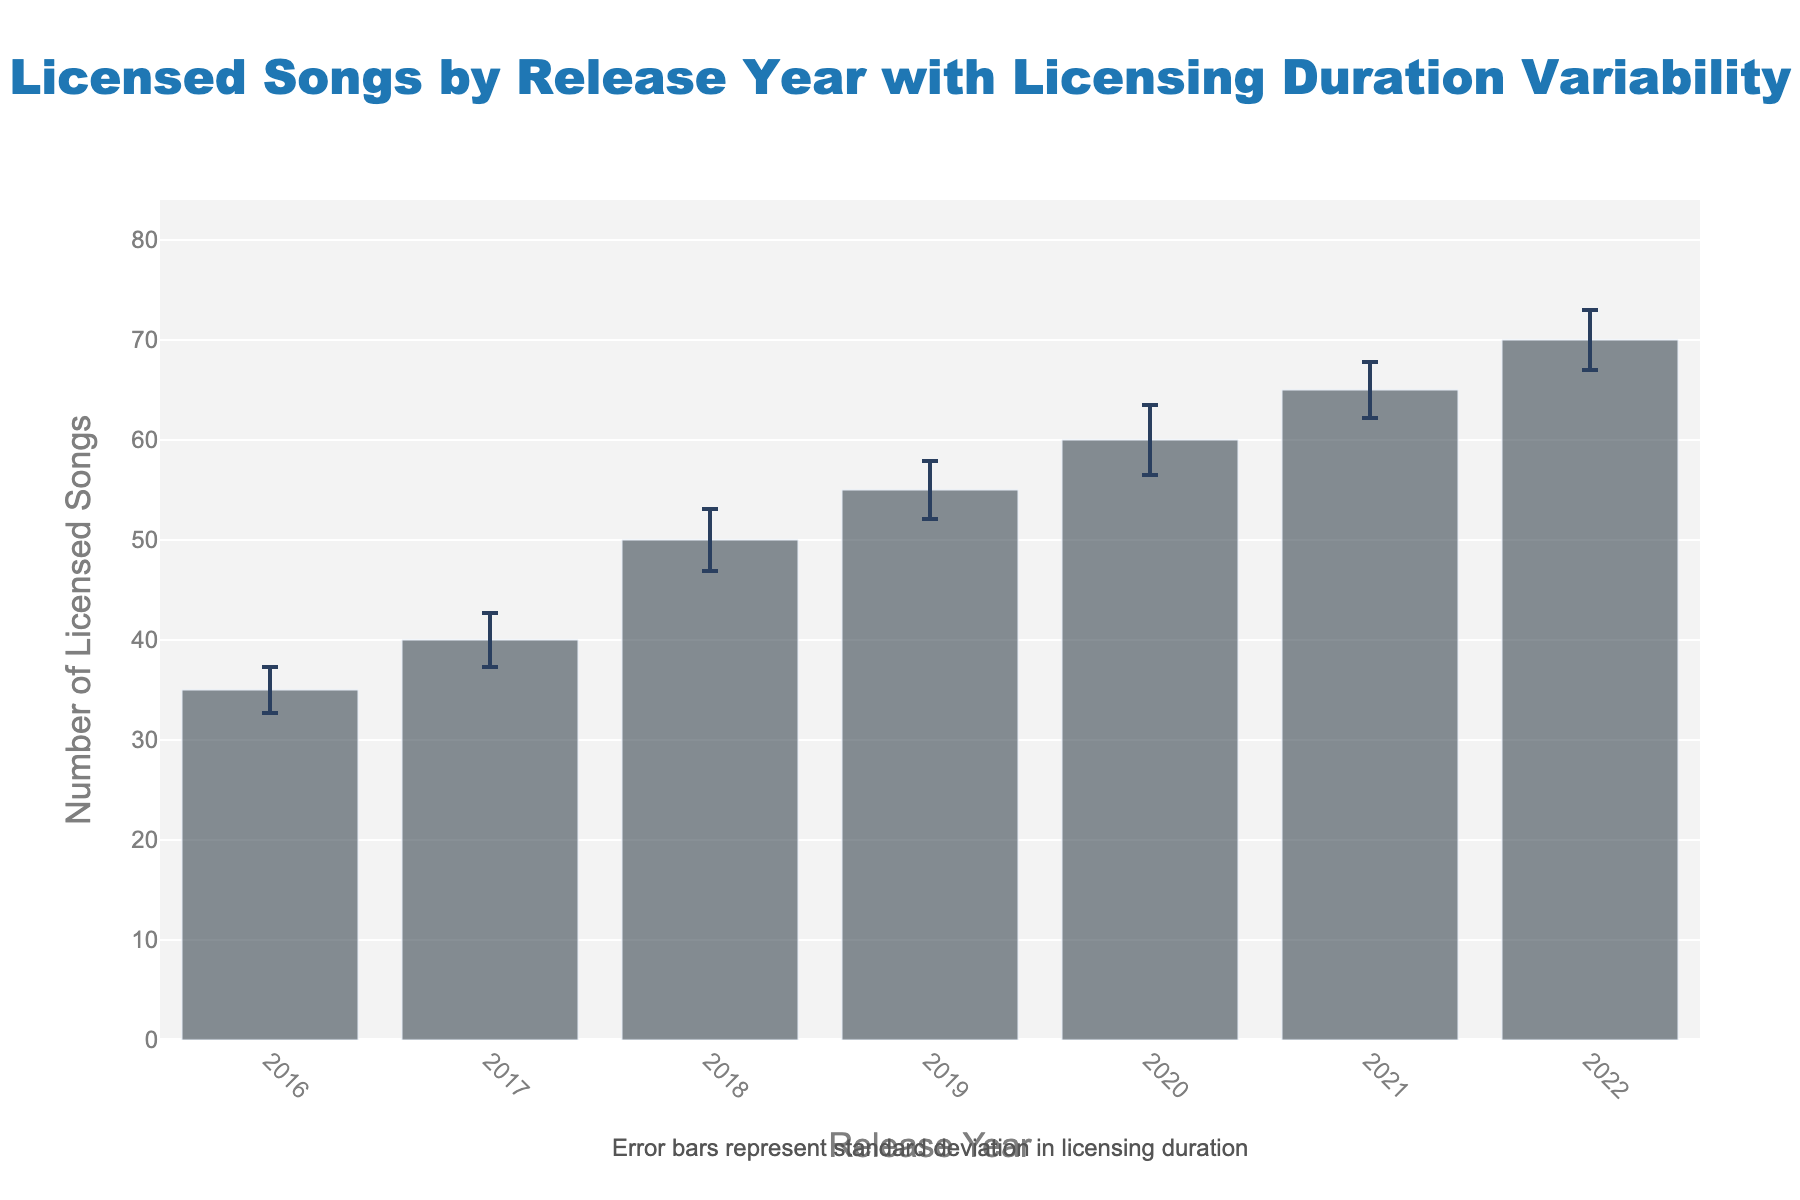What's the title of the figure? The title is displayed at the top of the figure. It reads "Licensed Songs by Release Year with Licensing Duration Variability".
Answer: Licensed Songs by Release Year with Licensing Duration Variability Which year had the highest number of licensed songs? Look for the year with the tallest bar. The bar for 2022 is the tallest indicating the highest number.
Answer: 2022 What is the approximate range of the y-axis? The y-axis range is set to slightly above the highest data point. The highest number of licensed songs is 70 and the y-axis range appears to go up to around 84 (70 * 1.2).
Answer: ~0 to 84 What do the error bars represent? The annotation at the bottom of the chart specifies that the error bars represent the standard deviation in licensing duration.
Answer: Standard deviation in licensing duration How many licensed songs were there in 2019, and what was the standard deviation? Refer to the bar for 2019. The bar height indicates 55 licensed songs, and the error bar's annotation indicates an SD of 2.9.
Answer: 55, 2.9 In which year was the standard deviation in licensing duration the highest? Compare the heights of the error bars. The error bar for 2020 is the tallest, indicating the highest standard deviation of 3.5.
Answer: 2020 How did the number of licensed songs change from 2017 to 2018? Compare the heights of the bars for 2017 and 2018. The height increased from 40 to 50.
Answer: Increased by 10 What was the total number of licensed songs from 2016 to 2018? Add the number of licensed songs for 2016, 2017, and 2018 (35 + 40 + 50).
Answer: 125 Which years saw an increase in the number of licensed songs compared to the previous year? Compare each year's bar height to the previous year's. All years (2017-2022) show an increase from the previous year.
Answer: 2017, 2018, 2019, 2020, 2021, 2022 Which year had the smallest standard deviation in licensing duration? Compare the error bar heights for all years. The error bar for 2016 is the shortest with an SD of 2.3.
Answer: 2016 